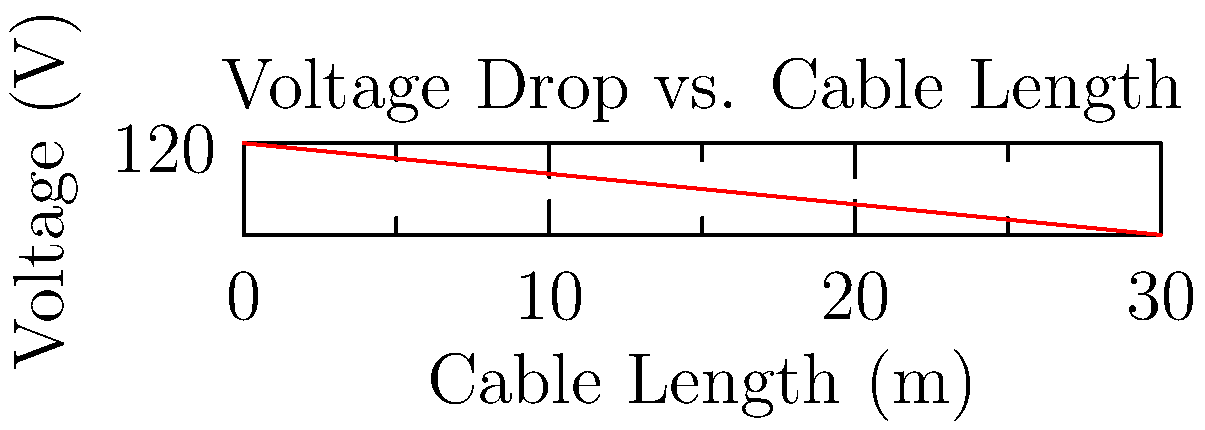You're planning an electrifying outdoor patio party for your restaurant. The lighting setup requires a 30-meter cable run. Given the voltage drop shown in the graph, what's the total voltage drop from the source to the end of the cable, and how might this affect your lighting ambiance? Let's break this down step-by-step:

1) The graph shows the voltage drop along a cable run from 0 to 30 meters.

2) At 0 meters (the source), the voltage is 120V.

3) At 30 meters (the end of the cable), the voltage has dropped to 117V.

4) To calculate the total voltage drop:
   $$\text{Voltage Drop} = \text{Source Voltage} - \text{End Voltage}$$
   $$\text{Voltage Drop} = 120V - 117V = 3V$$

5) This represents a drop of about 2.5% from the original voltage.

6) For lighting, a voltage drop of up to 3% is generally considered acceptable. However, it's at the upper limit of what's recommended.

7) The effect on lighting ambiance:
   - The lights at the end of the run may appear slightly dimmer than those closer to the source.
   - LED lights are less affected by voltage drops than incandescent bulbs.
   - The color temperature of the lights might shift slightly, potentially creating a warmer ambiance.

8) To maintain the desired lighting effect, you might consider:
   - Using a thicker gauge wire to reduce resistance and voltage drop.
   - Installing a buck-boost transformer to compensate for the voltage drop.
   - Distributing power from multiple sources along the run instead of a single end-feed.
Answer: 3V drop; may cause slight dimming and warmth in lighting at cable end. 